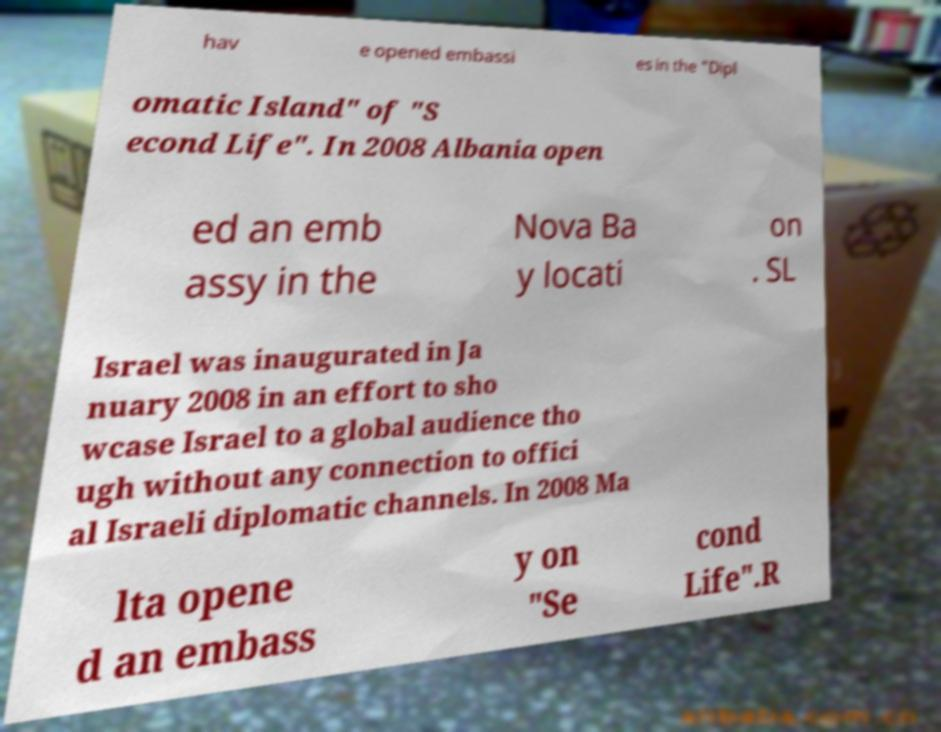Please identify and transcribe the text found in this image. hav e opened embassi es in the "Dipl omatic Island" of "S econd Life". In 2008 Albania open ed an emb assy in the Nova Ba y locati on . SL Israel was inaugurated in Ja nuary 2008 in an effort to sho wcase Israel to a global audience tho ugh without any connection to offici al Israeli diplomatic channels. In 2008 Ma lta opene d an embass y on "Se cond Life".R 